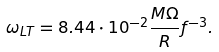Convert formula to latex. <formula><loc_0><loc_0><loc_500><loc_500>\omega _ { L T } = 8 . 4 4 \cdot 1 0 ^ { - 2 } \frac { M \Omega } { R } f ^ { - 3 } .</formula> 